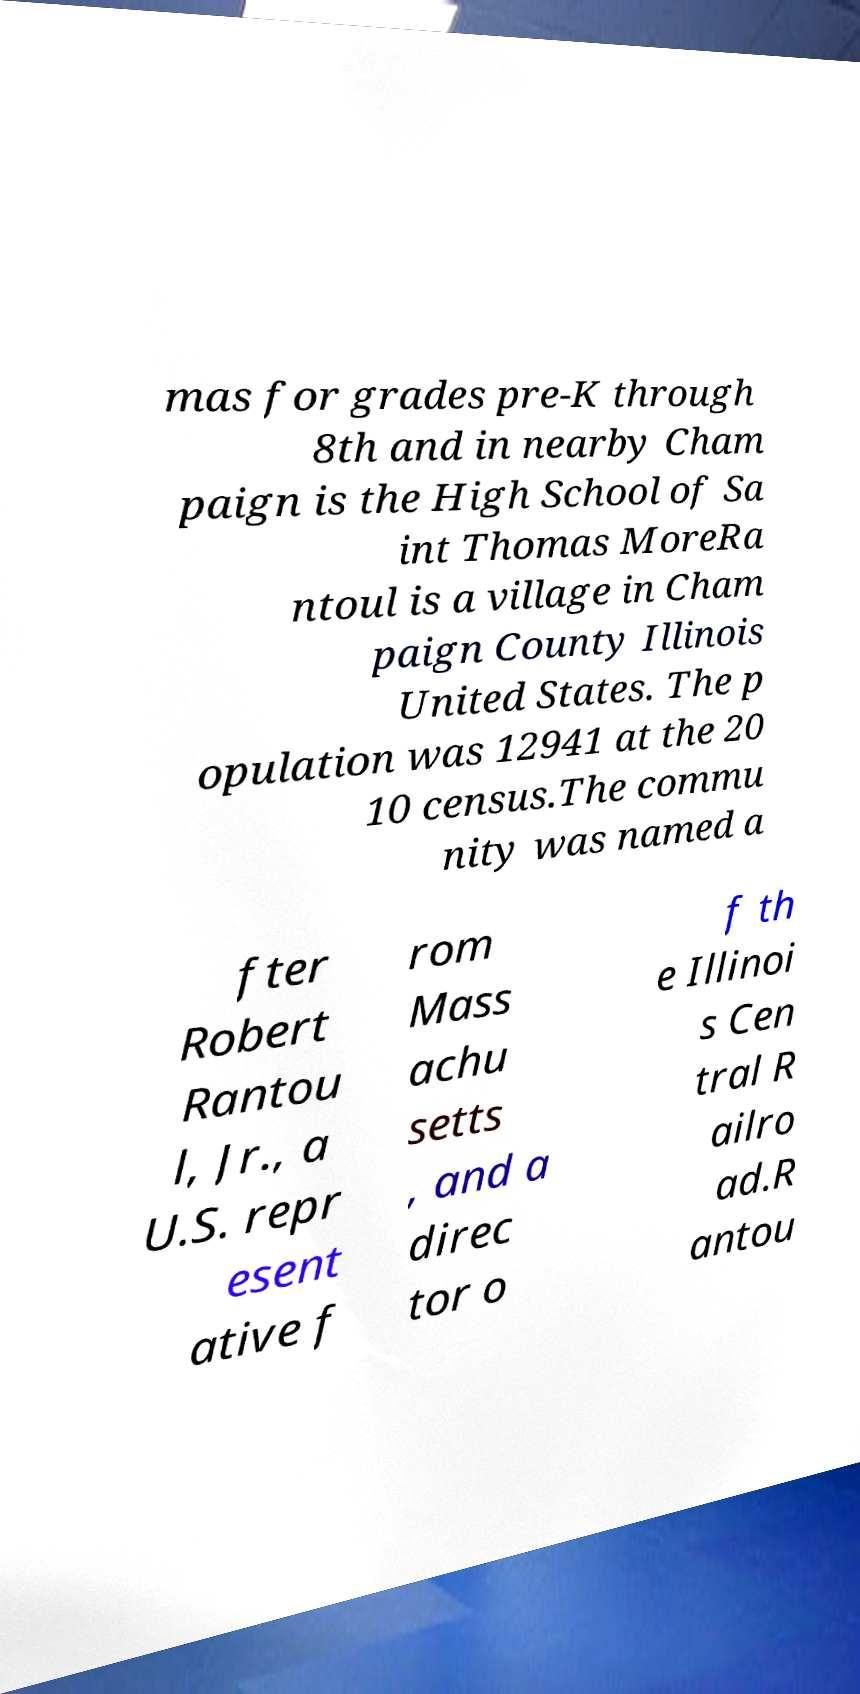I need the written content from this picture converted into text. Can you do that? mas for grades pre-K through 8th and in nearby Cham paign is the High School of Sa int Thomas MoreRa ntoul is a village in Cham paign County Illinois United States. The p opulation was 12941 at the 20 10 census.The commu nity was named a fter Robert Rantou l, Jr., a U.S. repr esent ative f rom Mass achu setts , and a direc tor o f th e Illinoi s Cen tral R ailro ad.R antou 